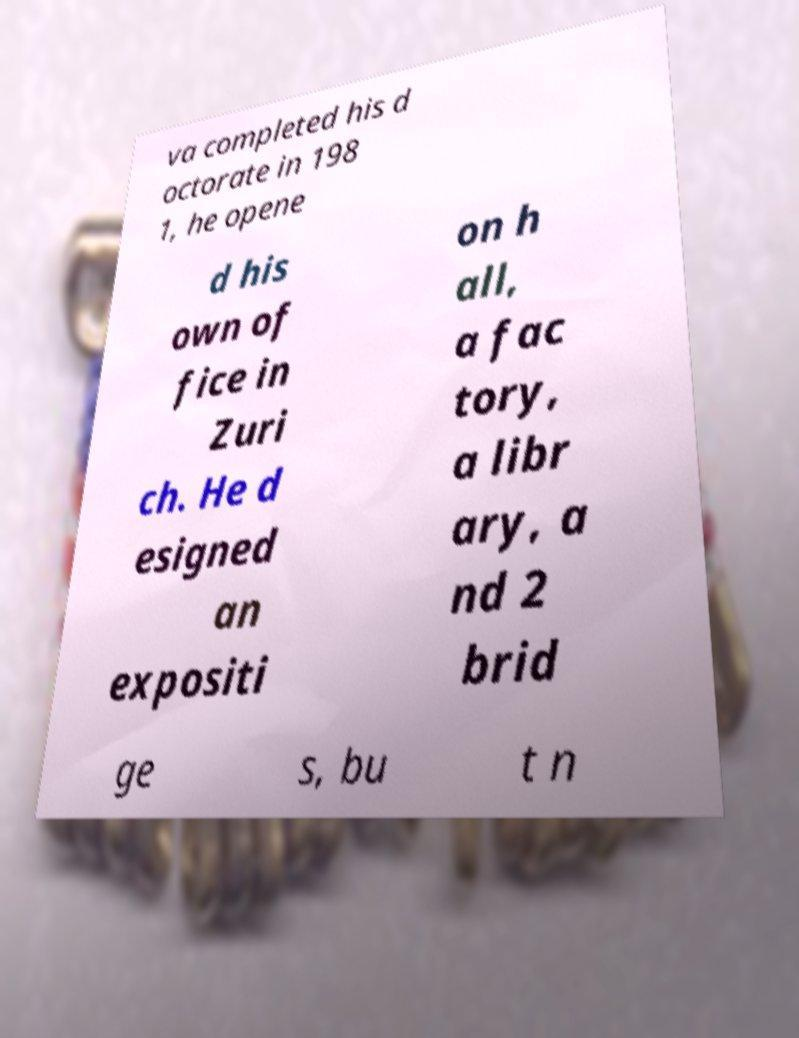Please identify and transcribe the text found in this image. va completed his d octorate in 198 1, he opene d his own of fice in Zuri ch. He d esigned an expositi on h all, a fac tory, a libr ary, a nd 2 brid ge s, bu t n 